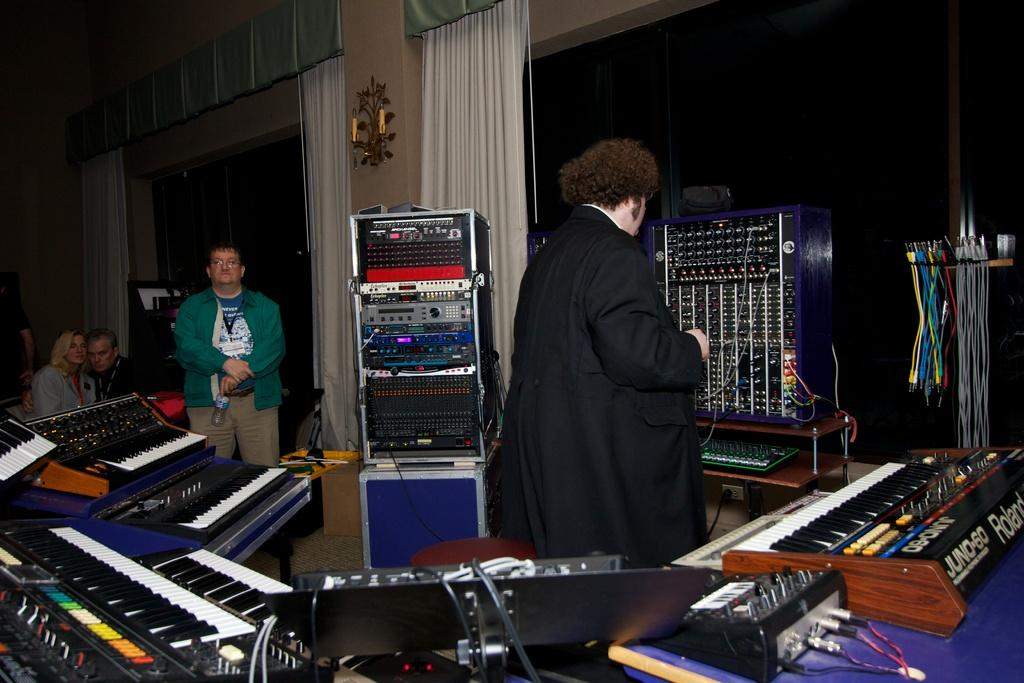What is the person in the image wearing? The person is wearing a black coat in the image. What is the person doing in the image? The person is standing in the image. What musical instrument is present in the image? There is a piano in the image. What devices are used for amplifying sound in the image? There are speakers in the image. Can you describe the people in the background of the image? There are people standing in the background of the image. What theory does the person in the image have about disgust? There is no indication in the image that the person has a theory about disgust, as the image focuses on the person's clothing and the presence of a piano and speakers. How many arms does the person in the image have? The image does not show the person's arms, so it is impossible to determine the number of arms they have. 